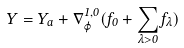<formula> <loc_0><loc_0><loc_500><loc_500>Y = Y _ { a } + \nabla _ { \varphi } ^ { 1 , 0 } ( f _ { 0 } + \sum _ { \lambda > 0 } f _ { \lambda } )</formula> 